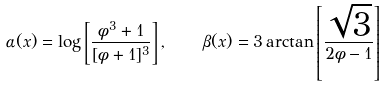Convert formula to latex. <formula><loc_0><loc_0><loc_500><loc_500>\alpha ( x ) = \log \left [ { \frac { \phi ^ { 3 } + 1 } { [ \phi + 1 ] ^ { 3 } } } \right ] , \quad \beta ( x ) = 3 \arctan \left [ { \frac { \sqrt { 3 } } { 2 \phi - 1 } } \right ]</formula> 